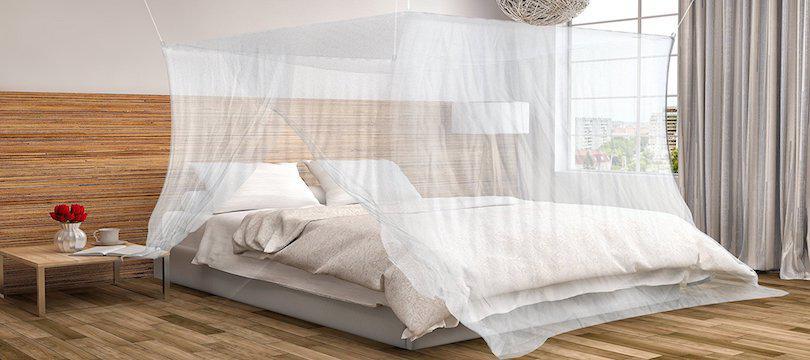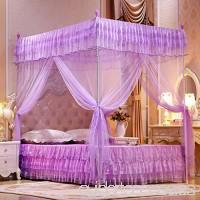The first image is the image on the left, the second image is the image on the right. For the images displayed, is the sentence "The bed canopy in the right image is purple." factually correct? Answer yes or no. Yes. The first image is the image on the left, the second image is the image on the right. Considering the images on both sides, is "Each bed is covered by a white canape." valid? Answer yes or no. No. 